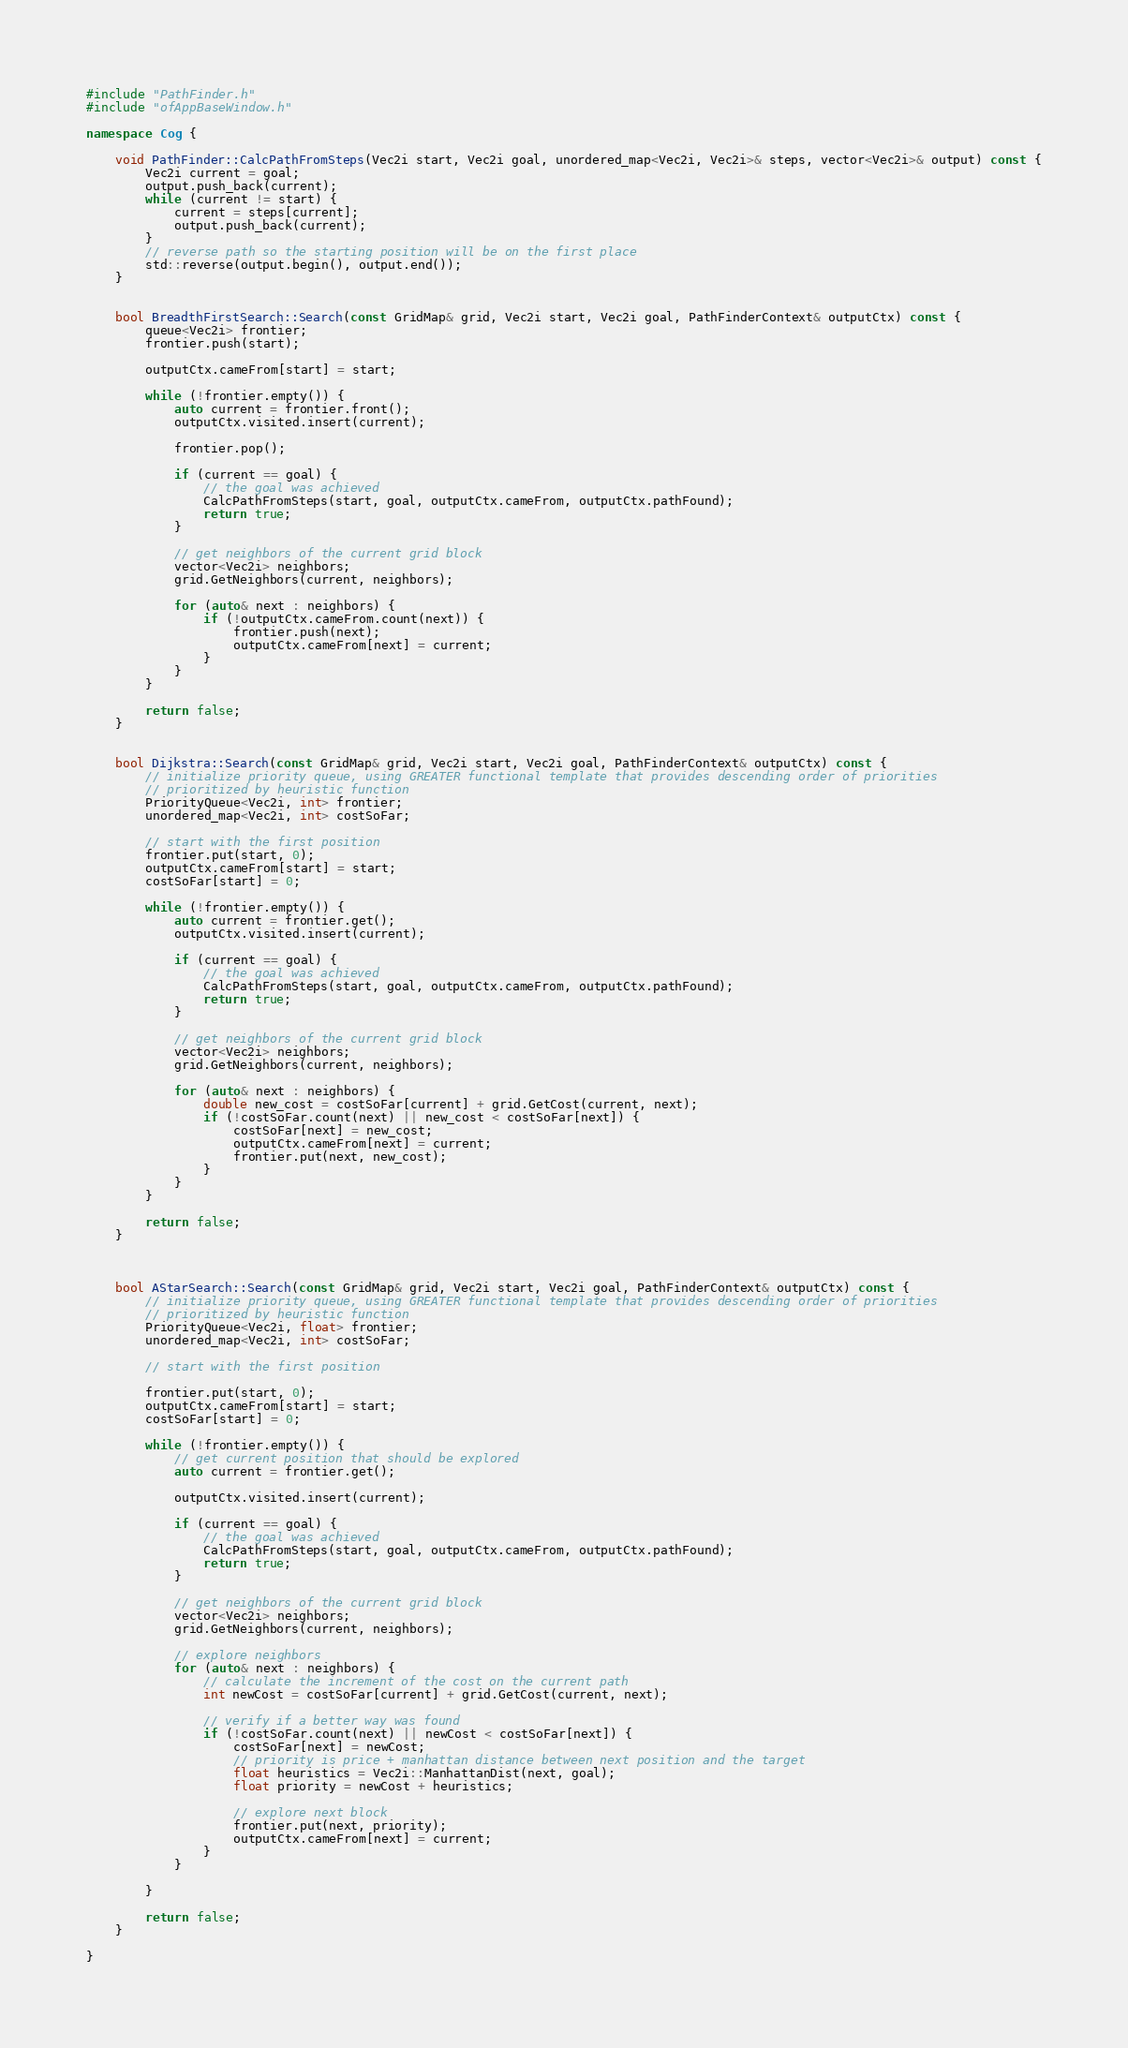Convert code to text. <code><loc_0><loc_0><loc_500><loc_500><_C++_>#include "PathFinder.h"
#include "ofAppBaseWindow.h"

namespace Cog {

	void PathFinder::CalcPathFromSteps(Vec2i start, Vec2i goal, unordered_map<Vec2i, Vec2i>& steps, vector<Vec2i>& output) const {
		Vec2i current = goal;
		output.push_back(current);
		while (current != start) {
			current = steps[current];
			output.push_back(current);
		}
		// reverse path so the starting position will be on the first place
		std::reverse(output.begin(), output.end());
	}


	bool BreadthFirstSearch::Search(const GridMap& grid, Vec2i start, Vec2i goal, PathFinderContext& outputCtx) const {
		queue<Vec2i> frontier;
		frontier.push(start);

		outputCtx.cameFrom[start] = start;

		while (!frontier.empty()) {
			auto current = frontier.front();
			outputCtx.visited.insert(current);

			frontier.pop();

			if (current == goal) {
				// the goal was achieved
				CalcPathFromSteps(start, goal, outputCtx.cameFrom, outputCtx.pathFound);
				return true;
			}

			// get neighbors of the current grid block
			vector<Vec2i> neighbors;
			grid.GetNeighbors(current, neighbors);

			for (auto& next : neighbors) {
				if (!outputCtx.cameFrom.count(next)) {
					frontier.push(next);
					outputCtx.cameFrom[next] = current;
				}
			}
		}

		return false;
	}


	bool Dijkstra::Search(const GridMap& grid, Vec2i start, Vec2i goal, PathFinderContext& outputCtx) const {
		// initialize priority queue, using GREATER functional template that provides descending order of priorities
		// prioritized by heuristic function
		PriorityQueue<Vec2i, int> frontier;
		unordered_map<Vec2i, int> costSoFar;

		// start with the first position
		frontier.put(start, 0);
		outputCtx.cameFrom[start] = start;
		costSoFar[start] = 0;

		while (!frontier.empty()) {
			auto current = frontier.get();
			outputCtx.visited.insert(current);

			if (current == goal) {
				// the goal was achieved
				CalcPathFromSteps(start, goal, outputCtx.cameFrom, outputCtx.pathFound);
				return true;
			}

			// get neighbors of the current grid block
			vector<Vec2i> neighbors;
			grid.GetNeighbors(current, neighbors);

			for (auto& next : neighbors) {
				double new_cost = costSoFar[current] + grid.GetCost(current, next);
				if (!costSoFar.count(next) || new_cost < costSoFar[next]) {
					costSoFar[next] = new_cost;
					outputCtx.cameFrom[next] = current;
					frontier.put(next, new_cost);
				}
			}
		}

		return false;
	}



	bool AStarSearch::Search(const GridMap& grid, Vec2i start, Vec2i goal, PathFinderContext& outputCtx) const {
		// initialize priority queue, using GREATER functional template that provides descending order of priorities
		// prioritized by heuristic function
		PriorityQueue<Vec2i, float> frontier;
		unordered_map<Vec2i, int> costSoFar;

		// start with the first position

		frontier.put(start, 0);
		outputCtx.cameFrom[start] = start;
		costSoFar[start] = 0;

		while (!frontier.empty()) {
			// get current position that should be explored
			auto current = frontier.get();

			outputCtx.visited.insert(current);

			if (current == goal) {
				// the goal was achieved
				CalcPathFromSteps(start, goal, outputCtx.cameFrom, outputCtx.pathFound);
				return true;
			}

			// get neighbors of the current grid block
			vector<Vec2i> neighbors;
			grid.GetNeighbors(current, neighbors);

			// explore neighbors
			for (auto& next : neighbors) {
				// calculate the increment of the cost on the current path
				int newCost = costSoFar[current] + grid.GetCost(current, next);

				// verify if a better way was found
				if (!costSoFar.count(next) || newCost < costSoFar[next]) {
					costSoFar[next] = newCost;
					// priority is price + manhattan distance between next position and the target
					float heuristics = Vec2i::ManhattanDist(next, goal);
					float priority = newCost + heuristics;

					// explore next block
					frontier.put(next, priority);
					outputCtx.cameFrom[next] = current;
				}
			}

		}

		return false;
	}

}</code> 